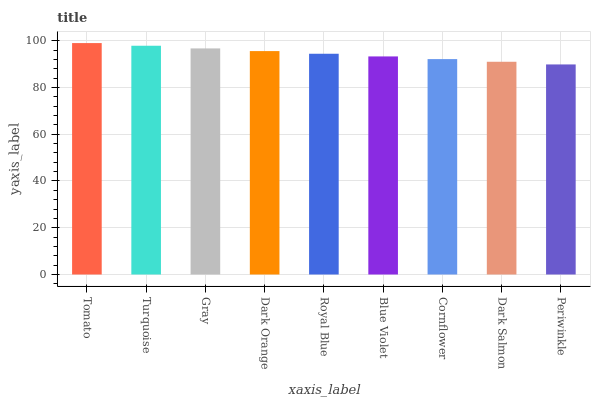Is Periwinkle the minimum?
Answer yes or no. Yes. Is Tomato the maximum?
Answer yes or no. Yes. Is Turquoise the minimum?
Answer yes or no. No. Is Turquoise the maximum?
Answer yes or no. No. Is Tomato greater than Turquoise?
Answer yes or no. Yes. Is Turquoise less than Tomato?
Answer yes or no. Yes. Is Turquoise greater than Tomato?
Answer yes or no. No. Is Tomato less than Turquoise?
Answer yes or no. No. Is Royal Blue the high median?
Answer yes or no. Yes. Is Royal Blue the low median?
Answer yes or no. Yes. Is Tomato the high median?
Answer yes or no. No. Is Dark Orange the low median?
Answer yes or no. No. 